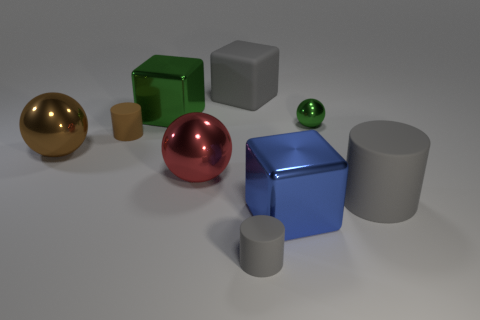Does the small gray thing that is to the left of the blue thing have the same material as the gray block?
Give a very brief answer. Yes. Does the big cube that is in front of the green metallic cube have the same material as the cube left of the big matte cube?
Give a very brief answer. Yes. Are there more big brown metal objects to the right of the brown metallic ball than yellow metal objects?
Keep it short and to the point. No. The big matte thing in front of the gray block behind the big blue object is what color?
Offer a very short reply. Gray. What is the shape of the green thing that is the same size as the blue cube?
Offer a terse response. Cube. What is the shape of the large thing that is the same color as the big rubber block?
Your answer should be very brief. Cylinder. Is the number of big balls right of the blue shiny cube the same as the number of blue cylinders?
Give a very brief answer. Yes. The large gray object that is behind the large gray thing that is on the right side of the small thing right of the large blue thing is made of what material?
Make the answer very short. Rubber. The small object that is the same material as the brown cylinder is what shape?
Your response must be concise. Cylinder. Are there any other things of the same color as the tiny metallic thing?
Provide a succinct answer. Yes. 